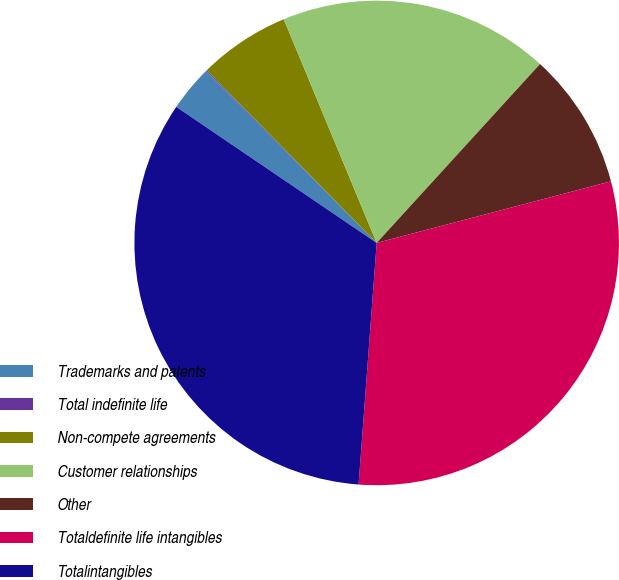<chart> <loc_0><loc_0><loc_500><loc_500><pie_chart><fcel>Trademarks and patents<fcel>Total indefinite life<fcel>Non-compete agreements<fcel>Customer relationships<fcel>Other<fcel>Totaldefinite life intangibles<fcel>Totalintangibles<nl><fcel>3.08%<fcel>0.06%<fcel>6.1%<fcel>18.04%<fcel>9.13%<fcel>30.28%<fcel>33.3%<nl></chart> 